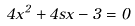Convert formula to latex. <formula><loc_0><loc_0><loc_500><loc_500>4 x ^ { 2 } + 4 s x - 3 = 0</formula> 